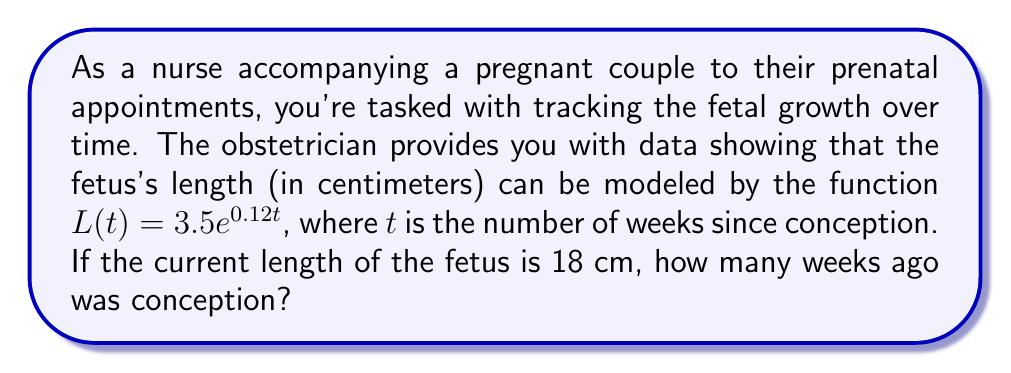Provide a solution to this math problem. To solve this problem, we'll use the given exponential function and the current length to determine the time since conception. Let's approach this step-by-step:

1) We're given the function $L(t) = 3.5e^{0.12t}$, where:
   $L(t)$ is the length of the fetus in centimeters
   $t$ is the time in weeks since conception

2) We know the current length is 18 cm, so we can set up the equation:
   $18 = 3.5e^{0.12t}$

3) To solve for $t$, we first divide both sides by 3.5:
   $\frac{18}{3.5} = e^{0.12t}$

4) Simplify:
   $5.1429 = e^{0.12t}$

5) Now, we take the natural logarithm of both sides:
   $\ln(5.1429) = \ln(e^{0.12t})$

6) The natural log and $e$ cancel on the right side:
   $\ln(5.1429) = 0.12t$

7) Now we can solve for $t$:
   $t = \frac{\ln(5.1429)}{0.12}$

8) Using a calculator:
   $t \approx 13.7143$ weeks

Therefore, conception occurred approximately 13.71 weeks ago.
Answer: 13.71 weeks 